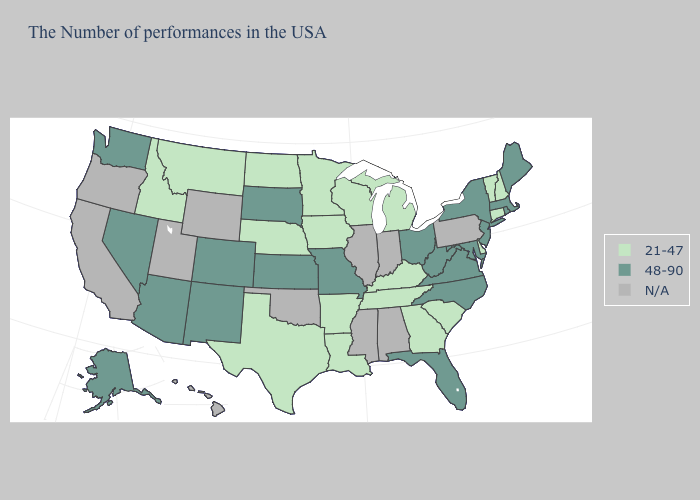Among the states that border Vermont , does New Hampshire have the lowest value?
Give a very brief answer. Yes. What is the highest value in the West ?
Be succinct. 48-90. Does the first symbol in the legend represent the smallest category?
Write a very short answer. Yes. Does Ohio have the lowest value in the MidWest?
Write a very short answer. No. What is the highest value in states that border Michigan?
Concise answer only. 48-90. What is the value of South Dakota?
Answer briefly. 48-90. What is the value of Alaska?
Keep it brief. 48-90. Which states have the highest value in the USA?
Short answer required. Maine, Massachusetts, Rhode Island, New York, New Jersey, Maryland, Virginia, North Carolina, West Virginia, Ohio, Florida, Missouri, Kansas, South Dakota, Colorado, New Mexico, Arizona, Nevada, Washington, Alaska. Does Colorado have the highest value in the USA?
Answer briefly. Yes. Does Massachusetts have the lowest value in the USA?
Short answer required. No. Does New York have the highest value in the USA?
Short answer required. Yes. Among the states that border Minnesota , does Iowa have the lowest value?
Keep it brief. Yes. Does West Virginia have the highest value in the South?
Give a very brief answer. Yes. Name the states that have a value in the range 48-90?
Concise answer only. Maine, Massachusetts, Rhode Island, New York, New Jersey, Maryland, Virginia, North Carolina, West Virginia, Ohio, Florida, Missouri, Kansas, South Dakota, Colorado, New Mexico, Arizona, Nevada, Washington, Alaska. 